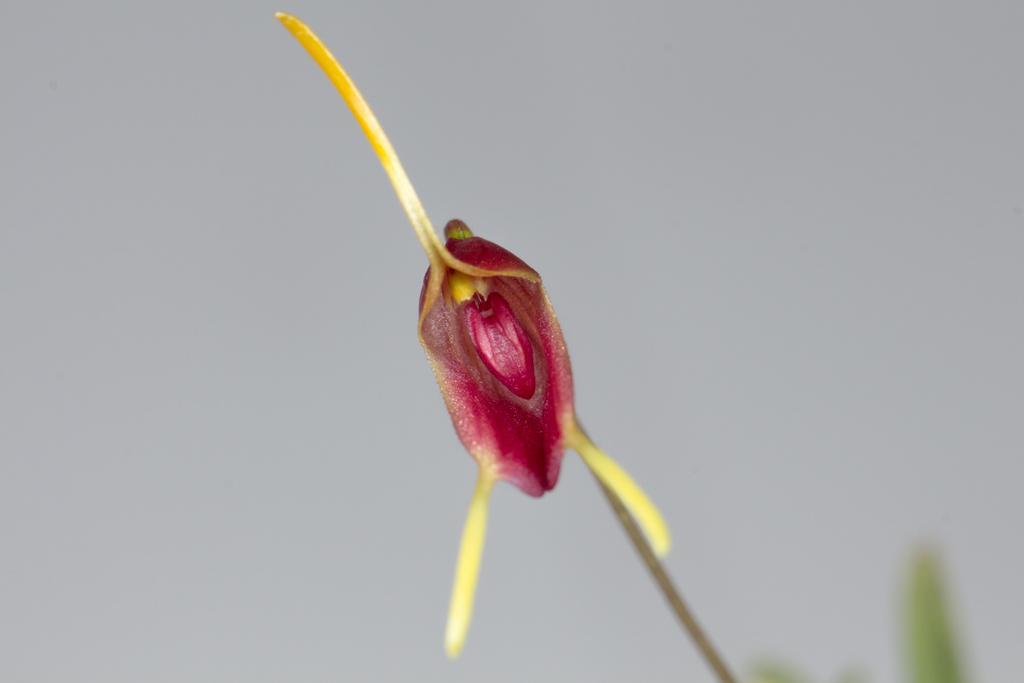What type of plant is visible in the image? There is a plant with a flower in the image. What other features can be seen on the plant? The plant has leaves. What can be seen in the background of the image? The sky is visible in the background of the image. What type of paste is being used for the distribution of the flowers in the image? There is no paste or distribution of flowers mentioned in the image; it simply shows a plant with a flower and leaves. 